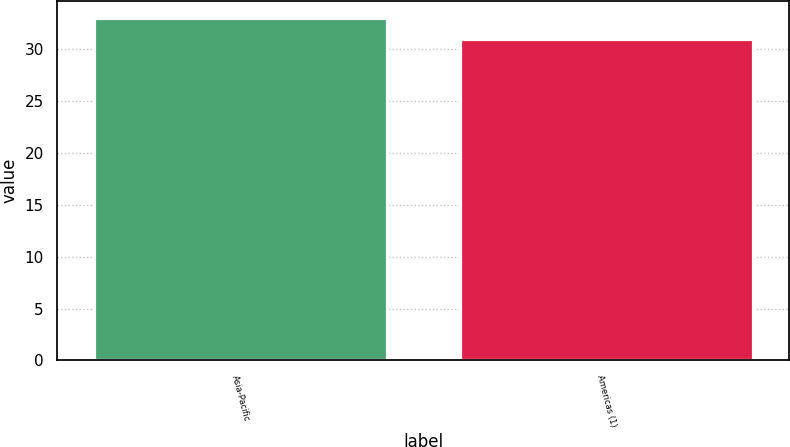Convert chart. <chart><loc_0><loc_0><loc_500><loc_500><bar_chart><fcel>Asia-Pacific<fcel>Americas (1)<nl><fcel>33<fcel>31<nl></chart> 